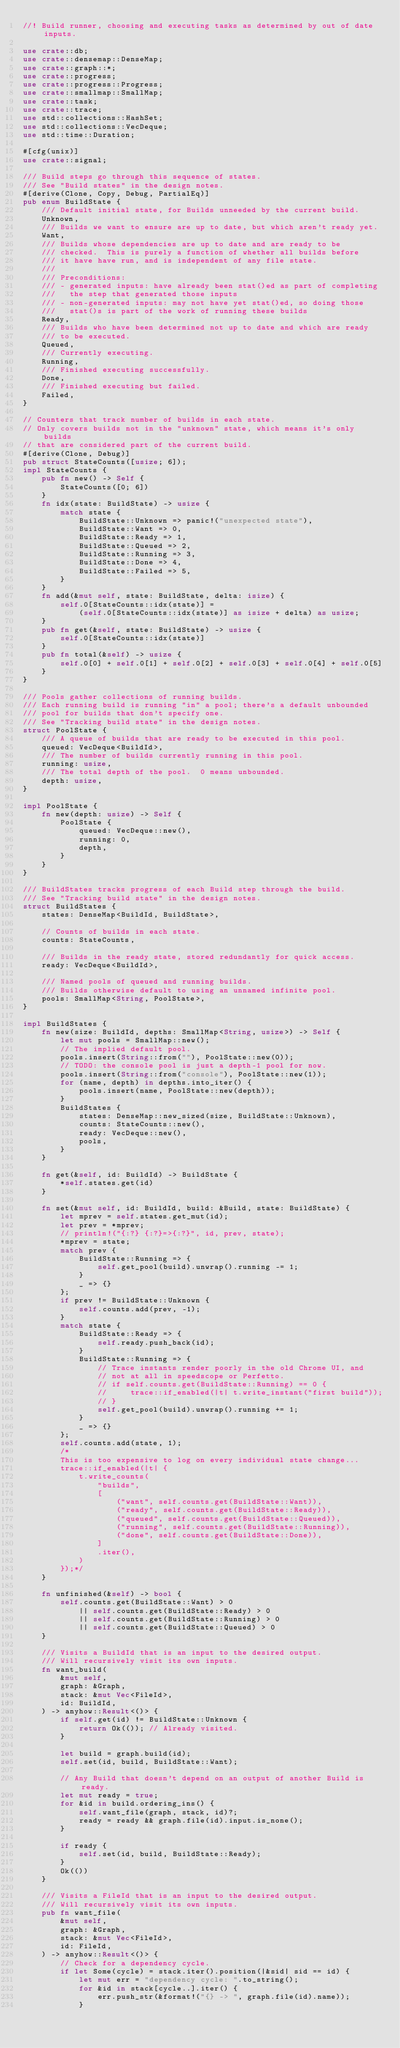Convert code to text. <code><loc_0><loc_0><loc_500><loc_500><_Rust_>//! Build runner, choosing and executing tasks as determined by out of date inputs.

use crate::db;
use crate::densemap::DenseMap;
use crate::graph::*;
use crate::progress;
use crate::progress::Progress;
use crate::smallmap::SmallMap;
use crate::task;
use crate::trace;
use std::collections::HashSet;
use std::collections::VecDeque;
use std::time::Duration;

#[cfg(unix)]
use crate::signal;

/// Build steps go through this sequence of states.
/// See "Build states" in the design notes.
#[derive(Clone, Copy, Debug, PartialEq)]
pub enum BuildState {
    /// Default initial state, for Builds unneeded by the current build.
    Unknown,
    /// Builds we want to ensure are up to date, but which aren't ready yet.
    Want,
    /// Builds whose dependencies are up to date and are ready to be
    /// checked.  This is purely a function of whether all builds before
    /// it have have run, and is independent of any file state.
    ///
    /// Preconditions:
    /// - generated inputs: have already been stat()ed as part of completing
    ///   the step that generated those inputs
    /// - non-generated inputs: may not have yet stat()ed, so doing those
    ///   stat()s is part of the work of running these builds
    Ready,
    /// Builds who have been determined not up to date and which are ready
    /// to be executed.
    Queued,
    /// Currently executing.
    Running,
    /// Finished executing successfully.
    Done,
    /// Finished executing but failed.
    Failed,
}

// Counters that track number of builds in each state.
// Only covers builds not in the "unknown" state, which means it's only builds
// that are considered part of the current build.
#[derive(Clone, Debug)]
pub struct StateCounts([usize; 6]);
impl StateCounts {
    pub fn new() -> Self {
        StateCounts([0; 6])
    }
    fn idx(state: BuildState) -> usize {
        match state {
            BuildState::Unknown => panic!("unexpected state"),
            BuildState::Want => 0,
            BuildState::Ready => 1,
            BuildState::Queued => 2,
            BuildState::Running => 3,
            BuildState::Done => 4,
            BuildState::Failed => 5,
        }
    }
    fn add(&mut self, state: BuildState, delta: isize) {
        self.0[StateCounts::idx(state)] =
            (self.0[StateCounts::idx(state)] as isize + delta) as usize;
    }
    pub fn get(&self, state: BuildState) -> usize {
        self.0[StateCounts::idx(state)]
    }
    pub fn total(&self) -> usize {
        self.0[0] + self.0[1] + self.0[2] + self.0[3] + self.0[4] + self.0[5]
    }
}

/// Pools gather collections of running builds.
/// Each running build is running "in" a pool; there's a default unbounded
/// pool for builds that don't specify one.
/// See "Tracking build state" in the design notes.
struct PoolState {
    /// A queue of builds that are ready to be executed in this pool.
    queued: VecDeque<BuildId>,
    /// The number of builds currently running in this pool.
    running: usize,
    /// The total depth of the pool.  0 means unbounded.
    depth: usize,
}

impl PoolState {
    fn new(depth: usize) -> Self {
        PoolState {
            queued: VecDeque::new(),
            running: 0,
            depth,
        }
    }
}

/// BuildStates tracks progress of each Build step through the build.
/// See "Tracking build state" in the design notes.
struct BuildStates {
    states: DenseMap<BuildId, BuildState>,

    // Counts of builds in each state.
    counts: StateCounts,

    /// Builds in the ready state, stored redundantly for quick access.
    ready: VecDeque<BuildId>,

    /// Named pools of queued and running builds.
    /// Builds otherwise default to using an unnamed infinite pool.
    pools: SmallMap<String, PoolState>,
}

impl BuildStates {
    fn new(size: BuildId, depths: SmallMap<String, usize>) -> Self {
        let mut pools = SmallMap::new();
        // The implied default pool.
        pools.insert(String::from(""), PoolState::new(0));
        // TODO: the console pool is just a depth-1 pool for now.
        pools.insert(String::from("console"), PoolState::new(1));
        for (name, depth) in depths.into_iter() {
            pools.insert(name, PoolState::new(depth));
        }
        BuildStates {
            states: DenseMap::new_sized(size, BuildState::Unknown),
            counts: StateCounts::new(),
            ready: VecDeque::new(),
            pools,
        }
    }

    fn get(&self, id: BuildId) -> BuildState {
        *self.states.get(id)
    }

    fn set(&mut self, id: BuildId, build: &Build, state: BuildState) {
        let mprev = self.states.get_mut(id);
        let prev = *mprev;
        // println!("{:?} {:?}=>{:?}", id, prev, state);
        *mprev = state;
        match prev {
            BuildState::Running => {
                self.get_pool(build).unwrap().running -= 1;
            }
            _ => {}
        };
        if prev != BuildState::Unknown {
            self.counts.add(prev, -1);
        }
        match state {
            BuildState::Ready => {
                self.ready.push_back(id);
            }
            BuildState::Running => {
                // Trace instants render poorly in the old Chrome UI, and
                // not at all in speedscope or Perfetto.
                // if self.counts.get(BuildState::Running) == 0 {
                //     trace::if_enabled(|t| t.write_instant("first build"));
                // }
                self.get_pool(build).unwrap().running += 1;
            }
            _ => {}
        };
        self.counts.add(state, 1);
        /*
        This is too expensive to log on every individual state change...
        trace::if_enabled(|t| {
            t.write_counts(
                "builds",
                [
                    ("want", self.counts.get(BuildState::Want)),
                    ("ready", self.counts.get(BuildState::Ready)),
                    ("queued", self.counts.get(BuildState::Queued)),
                    ("running", self.counts.get(BuildState::Running)),
                    ("done", self.counts.get(BuildState::Done)),
                ]
                .iter(),
            )
        });*/
    }

    fn unfinished(&self) -> bool {
        self.counts.get(BuildState::Want) > 0
            || self.counts.get(BuildState::Ready) > 0
            || self.counts.get(BuildState::Running) > 0
            || self.counts.get(BuildState::Queued) > 0
    }

    /// Visits a BuildId that is an input to the desired output.
    /// Will recursively visit its own inputs.
    fn want_build(
        &mut self,
        graph: &Graph,
        stack: &mut Vec<FileId>,
        id: BuildId,
    ) -> anyhow::Result<()> {
        if self.get(id) != BuildState::Unknown {
            return Ok(()); // Already visited.
        }

        let build = graph.build(id);
        self.set(id, build, BuildState::Want);

        // Any Build that doesn't depend on an output of another Build is ready.
        let mut ready = true;
        for &id in build.ordering_ins() {
            self.want_file(graph, stack, id)?;
            ready = ready && graph.file(id).input.is_none();
        }

        if ready {
            self.set(id, build, BuildState::Ready);
        }
        Ok(())
    }

    /// Visits a FileId that is an input to the desired output.
    /// Will recursively visit its own inputs.
    pub fn want_file(
        &mut self,
        graph: &Graph,
        stack: &mut Vec<FileId>,
        id: FileId,
    ) -> anyhow::Result<()> {
        // Check for a dependency cycle.
        if let Some(cycle) = stack.iter().position(|&sid| sid == id) {
            let mut err = "dependency cycle: ".to_string();
            for &id in stack[cycle..].iter() {
                err.push_str(&format!("{} -> ", graph.file(id).name));
            }</code> 